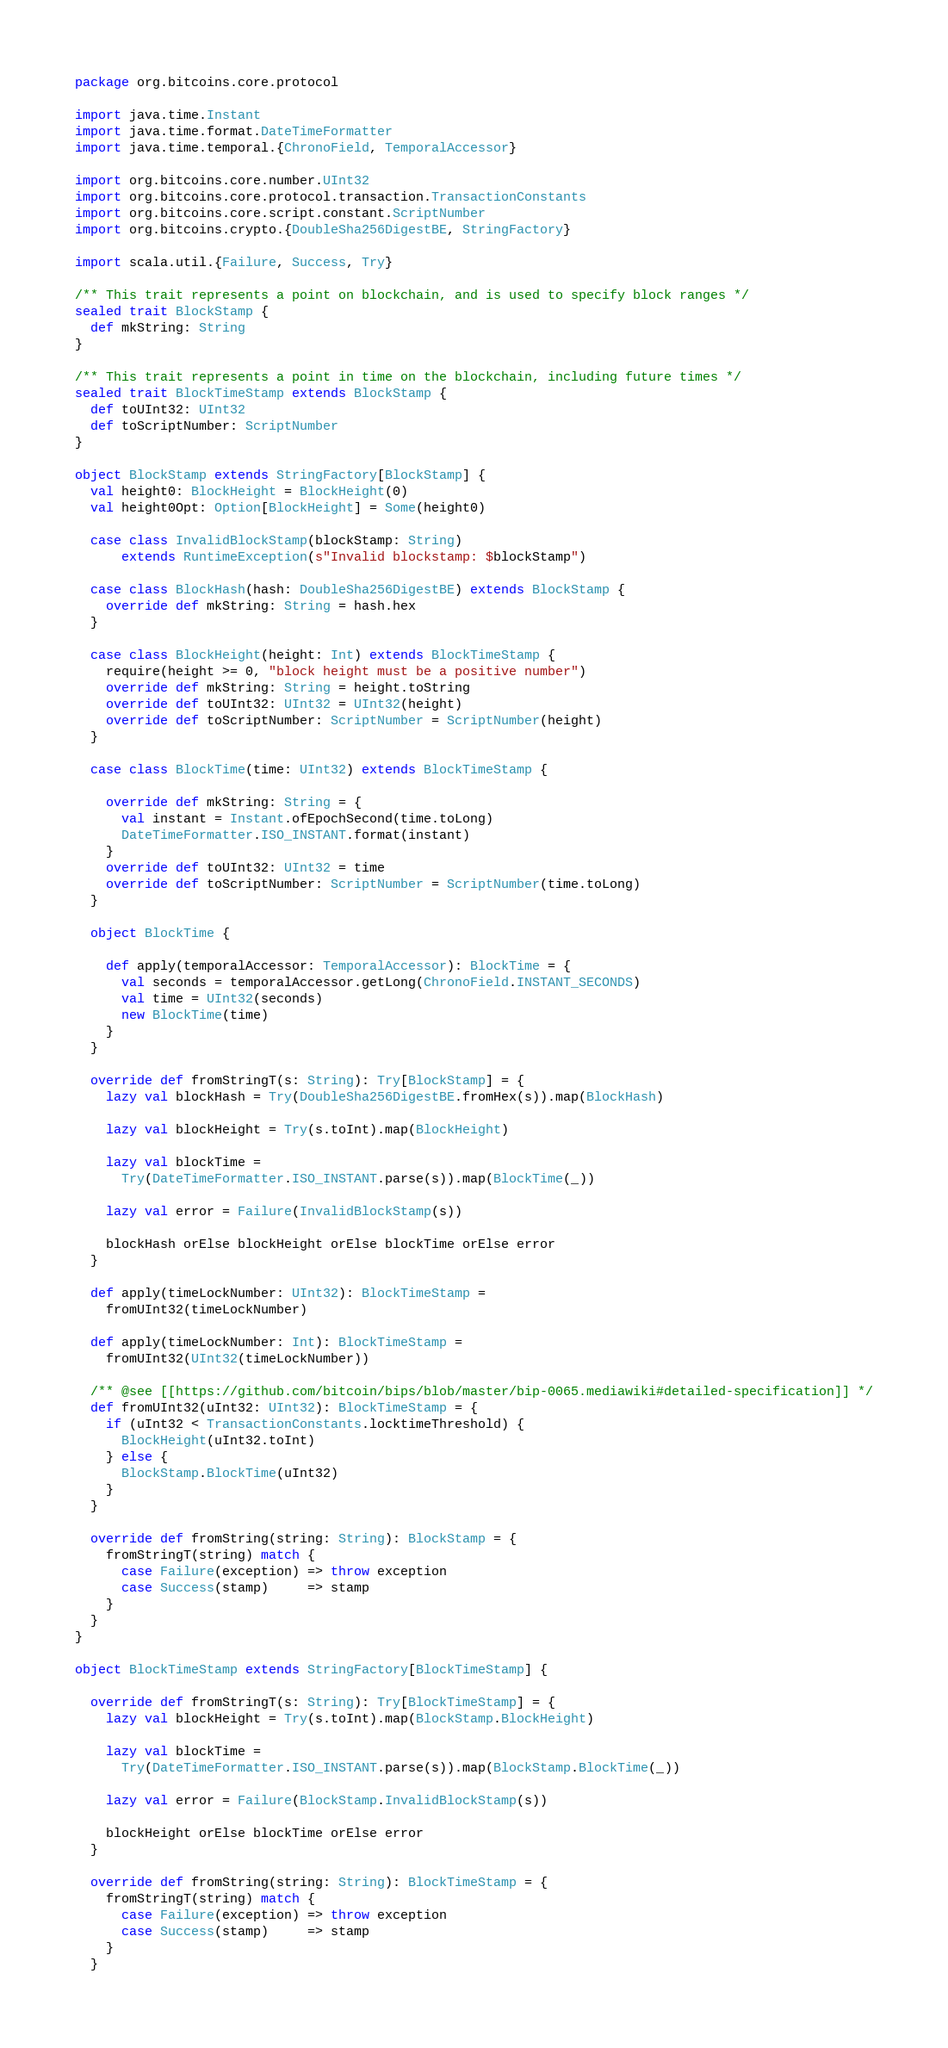<code> <loc_0><loc_0><loc_500><loc_500><_Scala_>package org.bitcoins.core.protocol

import java.time.Instant
import java.time.format.DateTimeFormatter
import java.time.temporal.{ChronoField, TemporalAccessor}

import org.bitcoins.core.number.UInt32
import org.bitcoins.core.protocol.transaction.TransactionConstants
import org.bitcoins.core.script.constant.ScriptNumber
import org.bitcoins.crypto.{DoubleSha256DigestBE, StringFactory}

import scala.util.{Failure, Success, Try}

/** This trait represents a point on blockchain, and is used to specify block ranges */
sealed trait BlockStamp {
  def mkString: String
}

/** This trait represents a point in time on the blockchain, including future times */
sealed trait BlockTimeStamp extends BlockStamp {
  def toUInt32: UInt32
  def toScriptNumber: ScriptNumber
}

object BlockStamp extends StringFactory[BlockStamp] {
  val height0: BlockHeight = BlockHeight(0)
  val height0Opt: Option[BlockHeight] = Some(height0)

  case class InvalidBlockStamp(blockStamp: String)
      extends RuntimeException(s"Invalid blockstamp: $blockStamp")

  case class BlockHash(hash: DoubleSha256DigestBE) extends BlockStamp {
    override def mkString: String = hash.hex
  }

  case class BlockHeight(height: Int) extends BlockTimeStamp {
    require(height >= 0, "block height must be a positive number")
    override def mkString: String = height.toString
    override def toUInt32: UInt32 = UInt32(height)
    override def toScriptNumber: ScriptNumber = ScriptNumber(height)
  }

  case class BlockTime(time: UInt32) extends BlockTimeStamp {

    override def mkString: String = {
      val instant = Instant.ofEpochSecond(time.toLong)
      DateTimeFormatter.ISO_INSTANT.format(instant)
    }
    override def toUInt32: UInt32 = time
    override def toScriptNumber: ScriptNumber = ScriptNumber(time.toLong)
  }

  object BlockTime {

    def apply(temporalAccessor: TemporalAccessor): BlockTime = {
      val seconds = temporalAccessor.getLong(ChronoField.INSTANT_SECONDS)
      val time = UInt32(seconds)
      new BlockTime(time)
    }
  }

  override def fromStringT(s: String): Try[BlockStamp] = {
    lazy val blockHash = Try(DoubleSha256DigestBE.fromHex(s)).map(BlockHash)

    lazy val blockHeight = Try(s.toInt).map(BlockHeight)

    lazy val blockTime =
      Try(DateTimeFormatter.ISO_INSTANT.parse(s)).map(BlockTime(_))

    lazy val error = Failure(InvalidBlockStamp(s))

    blockHash orElse blockHeight orElse blockTime orElse error
  }

  def apply(timeLockNumber: UInt32): BlockTimeStamp =
    fromUInt32(timeLockNumber)

  def apply(timeLockNumber: Int): BlockTimeStamp =
    fromUInt32(UInt32(timeLockNumber))

  /** @see [[https://github.com/bitcoin/bips/blob/master/bip-0065.mediawiki#detailed-specification]] */
  def fromUInt32(uInt32: UInt32): BlockTimeStamp = {
    if (uInt32 < TransactionConstants.locktimeThreshold) {
      BlockHeight(uInt32.toInt)
    } else {
      BlockStamp.BlockTime(uInt32)
    }
  }

  override def fromString(string: String): BlockStamp = {
    fromStringT(string) match {
      case Failure(exception) => throw exception
      case Success(stamp)     => stamp
    }
  }
}

object BlockTimeStamp extends StringFactory[BlockTimeStamp] {

  override def fromStringT(s: String): Try[BlockTimeStamp] = {
    lazy val blockHeight = Try(s.toInt).map(BlockStamp.BlockHeight)

    lazy val blockTime =
      Try(DateTimeFormatter.ISO_INSTANT.parse(s)).map(BlockStamp.BlockTime(_))

    lazy val error = Failure(BlockStamp.InvalidBlockStamp(s))

    blockHeight orElse blockTime orElse error
  }

  override def fromString(string: String): BlockTimeStamp = {
    fromStringT(string) match {
      case Failure(exception) => throw exception
      case Success(stamp)     => stamp
    }
  }
</code> 